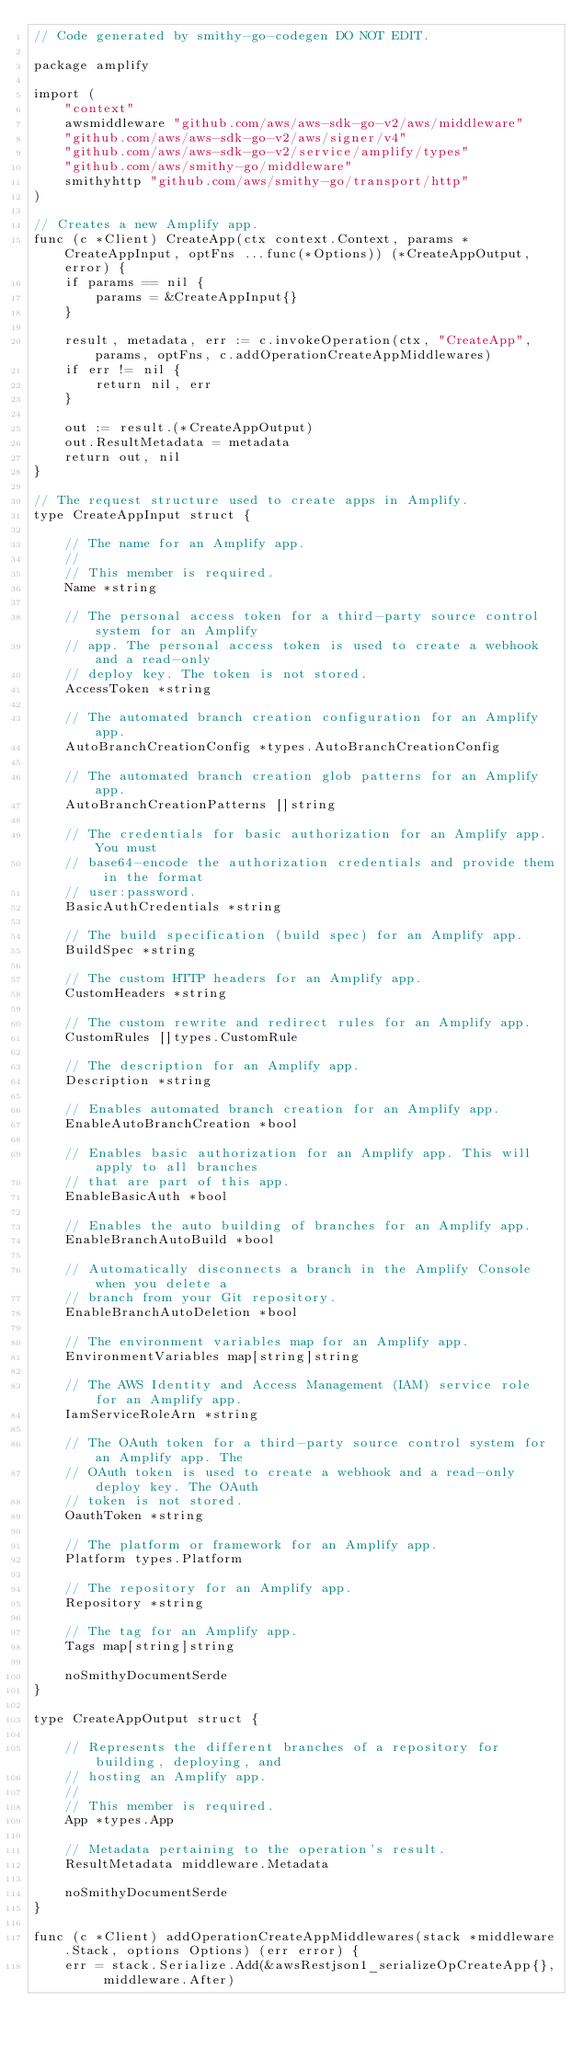Convert code to text. <code><loc_0><loc_0><loc_500><loc_500><_Go_>// Code generated by smithy-go-codegen DO NOT EDIT.

package amplify

import (
	"context"
	awsmiddleware "github.com/aws/aws-sdk-go-v2/aws/middleware"
	"github.com/aws/aws-sdk-go-v2/aws/signer/v4"
	"github.com/aws/aws-sdk-go-v2/service/amplify/types"
	"github.com/aws/smithy-go/middleware"
	smithyhttp "github.com/aws/smithy-go/transport/http"
)

// Creates a new Amplify app.
func (c *Client) CreateApp(ctx context.Context, params *CreateAppInput, optFns ...func(*Options)) (*CreateAppOutput, error) {
	if params == nil {
		params = &CreateAppInput{}
	}

	result, metadata, err := c.invokeOperation(ctx, "CreateApp", params, optFns, c.addOperationCreateAppMiddlewares)
	if err != nil {
		return nil, err
	}

	out := result.(*CreateAppOutput)
	out.ResultMetadata = metadata
	return out, nil
}

// The request structure used to create apps in Amplify.
type CreateAppInput struct {

	// The name for an Amplify app.
	//
	// This member is required.
	Name *string

	// The personal access token for a third-party source control system for an Amplify
	// app. The personal access token is used to create a webhook and a read-only
	// deploy key. The token is not stored.
	AccessToken *string

	// The automated branch creation configuration for an Amplify app.
	AutoBranchCreationConfig *types.AutoBranchCreationConfig

	// The automated branch creation glob patterns for an Amplify app.
	AutoBranchCreationPatterns []string

	// The credentials for basic authorization for an Amplify app. You must
	// base64-encode the authorization credentials and provide them in the format
	// user:password.
	BasicAuthCredentials *string

	// The build specification (build spec) for an Amplify app.
	BuildSpec *string

	// The custom HTTP headers for an Amplify app.
	CustomHeaders *string

	// The custom rewrite and redirect rules for an Amplify app.
	CustomRules []types.CustomRule

	// The description for an Amplify app.
	Description *string

	// Enables automated branch creation for an Amplify app.
	EnableAutoBranchCreation *bool

	// Enables basic authorization for an Amplify app. This will apply to all branches
	// that are part of this app.
	EnableBasicAuth *bool

	// Enables the auto building of branches for an Amplify app.
	EnableBranchAutoBuild *bool

	// Automatically disconnects a branch in the Amplify Console when you delete a
	// branch from your Git repository.
	EnableBranchAutoDeletion *bool

	// The environment variables map for an Amplify app.
	EnvironmentVariables map[string]string

	// The AWS Identity and Access Management (IAM) service role for an Amplify app.
	IamServiceRoleArn *string

	// The OAuth token for a third-party source control system for an Amplify app. The
	// OAuth token is used to create a webhook and a read-only deploy key. The OAuth
	// token is not stored.
	OauthToken *string

	// The platform or framework for an Amplify app.
	Platform types.Platform

	// The repository for an Amplify app.
	Repository *string

	// The tag for an Amplify app.
	Tags map[string]string

	noSmithyDocumentSerde
}

type CreateAppOutput struct {

	// Represents the different branches of a repository for building, deploying, and
	// hosting an Amplify app.
	//
	// This member is required.
	App *types.App

	// Metadata pertaining to the operation's result.
	ResultMetadata middleware.Metadata

	noSmithyDocumentSerde
}

func (c *Client) addOperationCreateAppMiddlewares(stack *middleware.Stack, options Options) (err error) {
	err = stack.Serialize.Add(&awsRestjson1_serializeOpCreateApp{}, middleware.After)</code> 